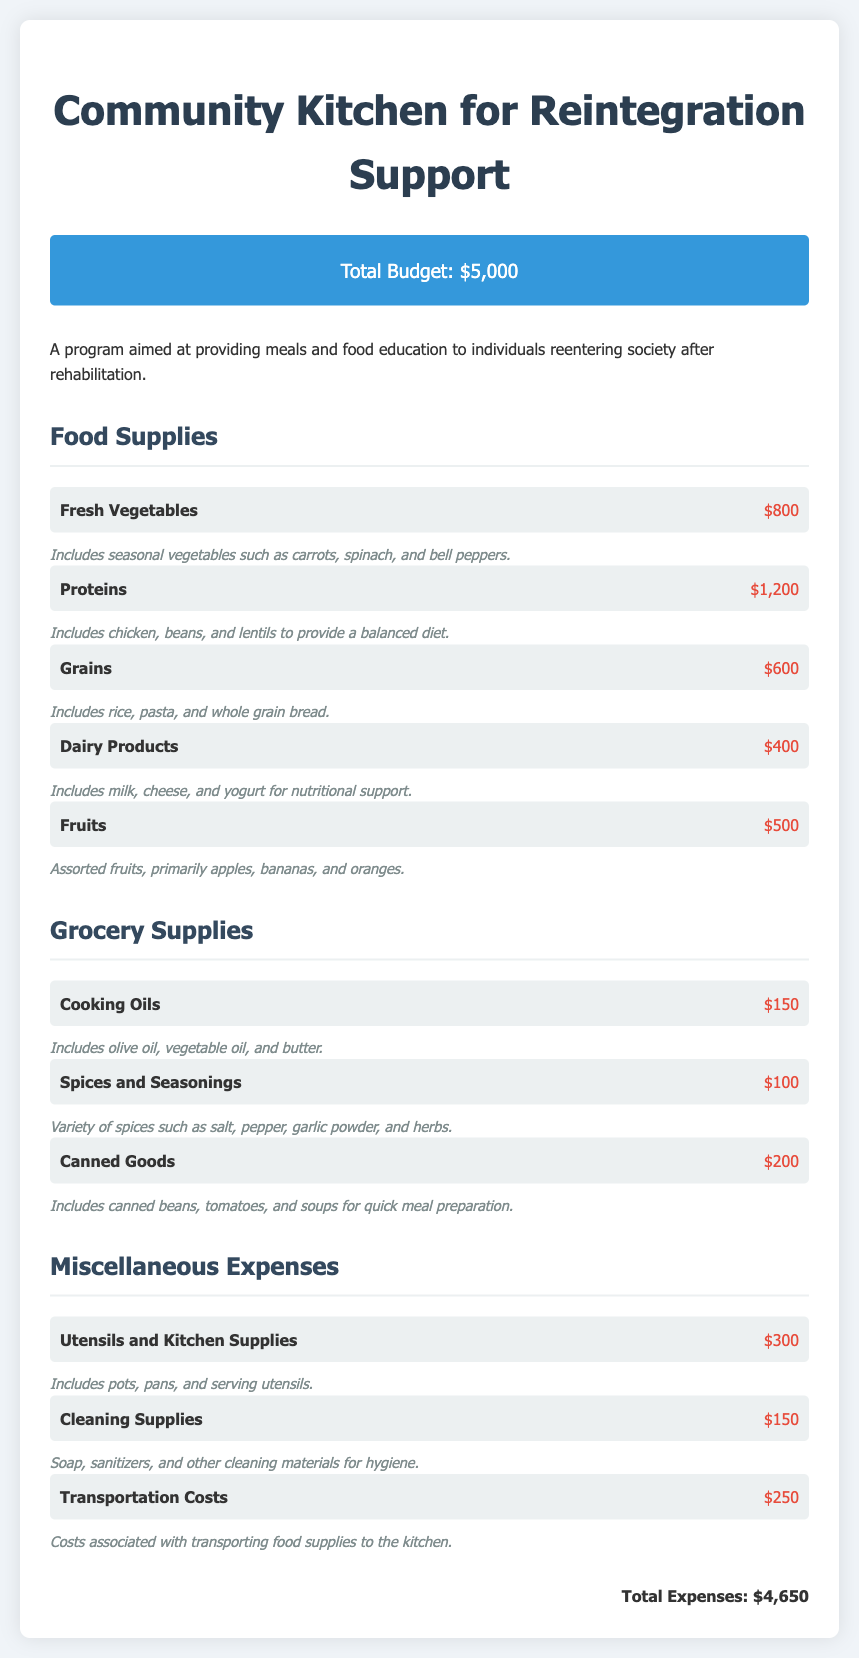What is the total budget? The total budget listed in the document is $5,000.
Answer: $5,000 How much is allocated for proteins? The document specifies an allocation of $1,200 for proteins.
Answer: $1,200 What is the cost of fresh vegetables? The cost for fresh vegetables mentioned in the document is $800.
Answer: $800 How much is spent on cooking oils? The budget states that cooking oils cost $150.
Answer: $150 What is the total amount spent on grocery supplies? The total cost for grocery supplies can be calculated as $150 + $100 + $200 = $450.
Answer: $450 What is the total expense amount? The total expenses in the document amount to $4,650.
Answer: $4,650 What item falls under miscellaneous expenses costing $300? The item listed under miscellaneous expenses costing $300 is utensils and kitchen supplies.
Answer: Utensils and Kitchen Supplies Which category includes canned goods? The category that includes canned goods is grocery supplies.
Answer: Grocery Supplies What is the cost associated with transportation? The cost for transportation mentioned in the document is $250.
Answer: $250 